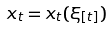Convert formula to latex. <formula><loc_0><loc_0><loc_500><loc_500>x _ { t } = x _ { t } ( \xi _ { [ t ] } )</formula> 